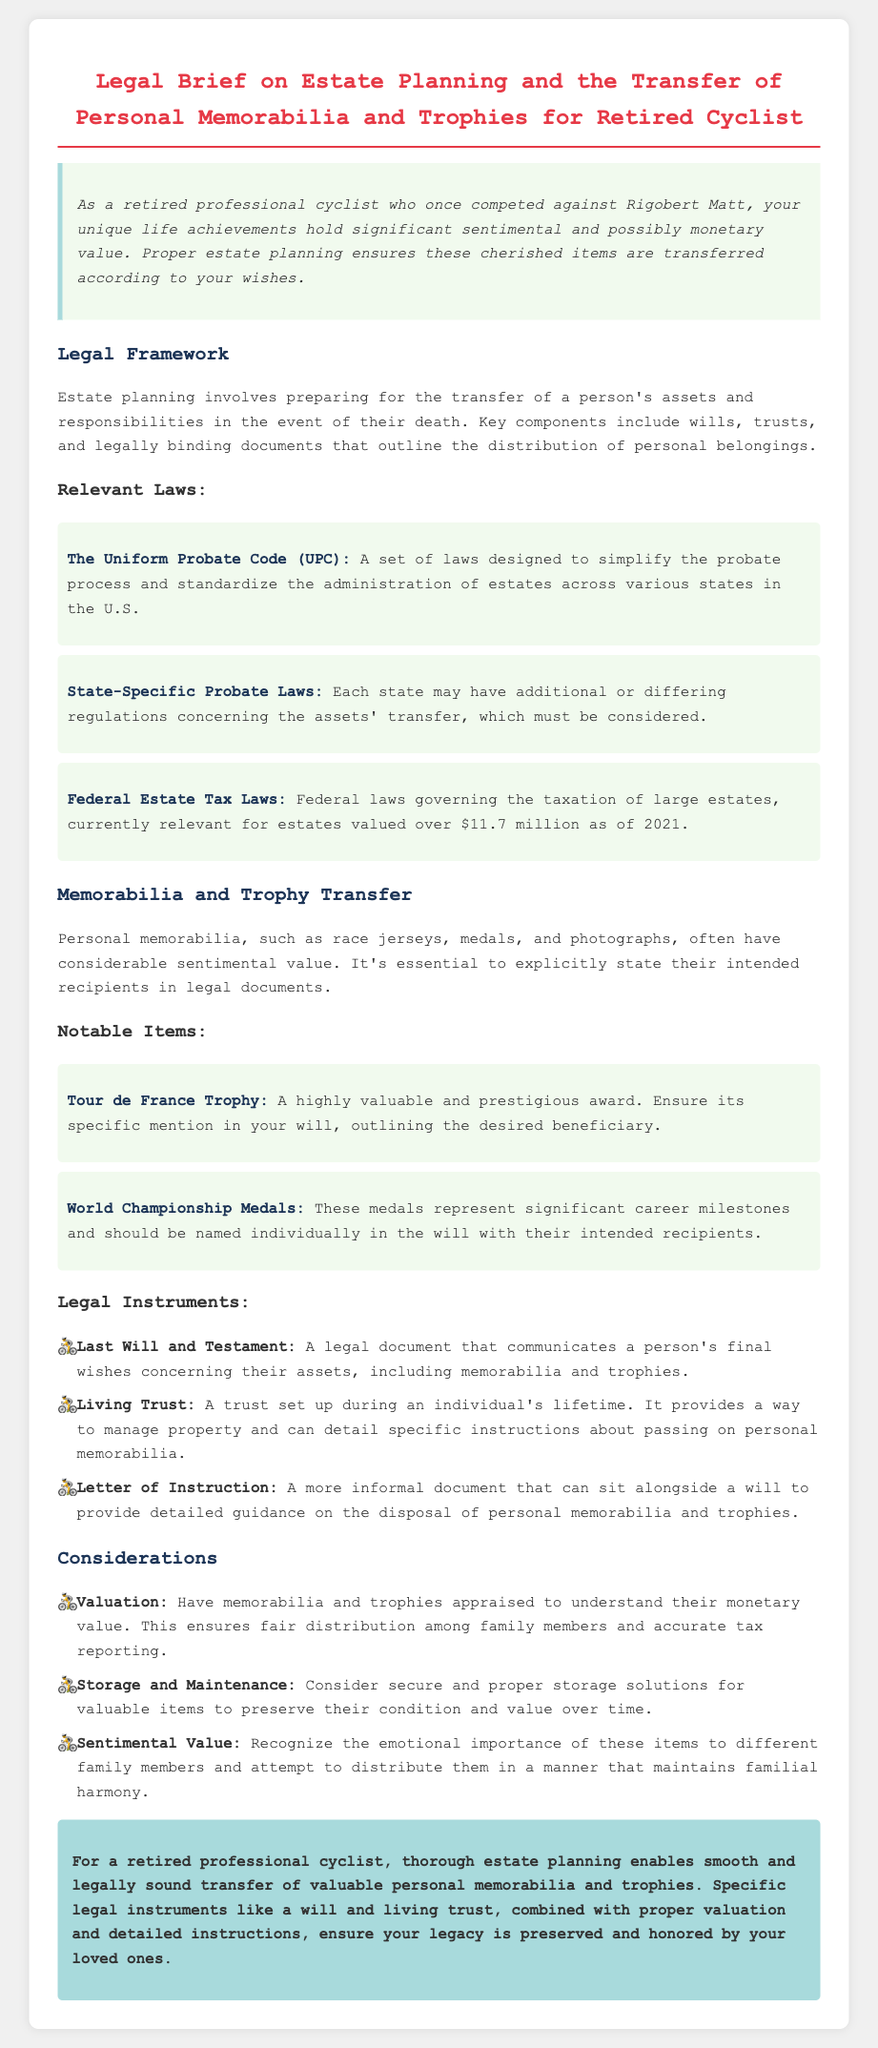what is the title of the document? The title of the document is centered at the top of the legal brief and clearly stated.
Answer: Legal Brief on Estate Planning and the Transfer of Personal Memorabilia and Trophies for Retired Cyclist what is the primary focus of the estate planning in the document? The focus is on ensuring the transfer of personal memorabilia and trophies to family members.
Answer: Transfer of personal memorabilia and trophies which federal laws are mentioned regarding estate tax? The document explicitly refers to laws that govern the taxation of large estates.
Answer: Federal Estate Tax Laws what item is highlighted for its high value and prestige? This item is specifically mentioned as having significant value and is associated with cycling achievement.
Answer: Tour de France Trophy how many relevant laws are listed in the document? The document enumerates the different laws important for estate planning, giving a total count.
Answer: Three what is one legal instrument mentioned for managing personal memorabilia? The document lists various instruments, and one example is provided as a way to communicate wishes.
Answer: Last Will and Testament what aspect should be considered to maintain familial harmony? This refers to the emotional impact and importance of the items on family members when distributing them.
Answer: Sentimental Value who is the intended audience of this legal brief? The introduction specifies who the content is aimed at regarding personal achievements and items.
Answer: Retired professional cyclist 